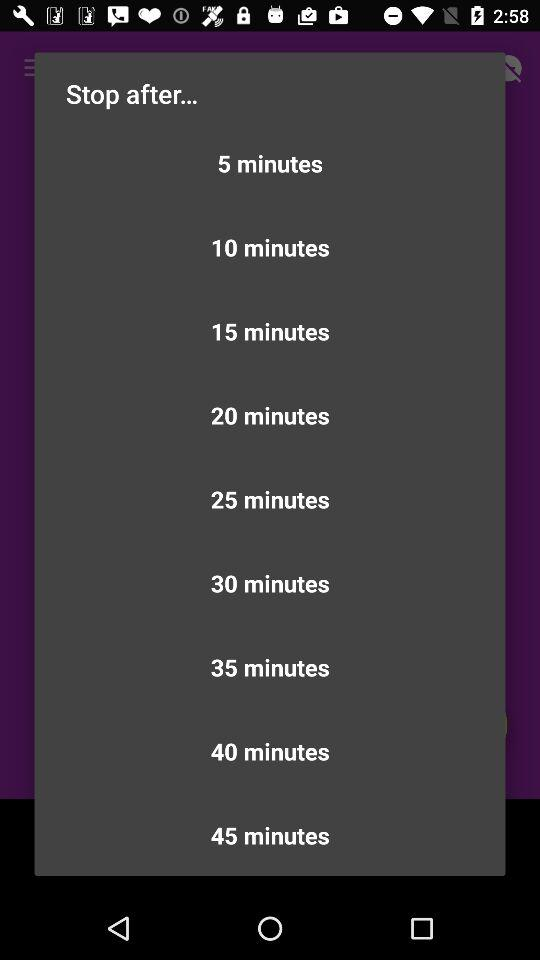How many minutes are between the 5 minute option and the 30 minute option?
Answer the question using a single word or phrase. 25 